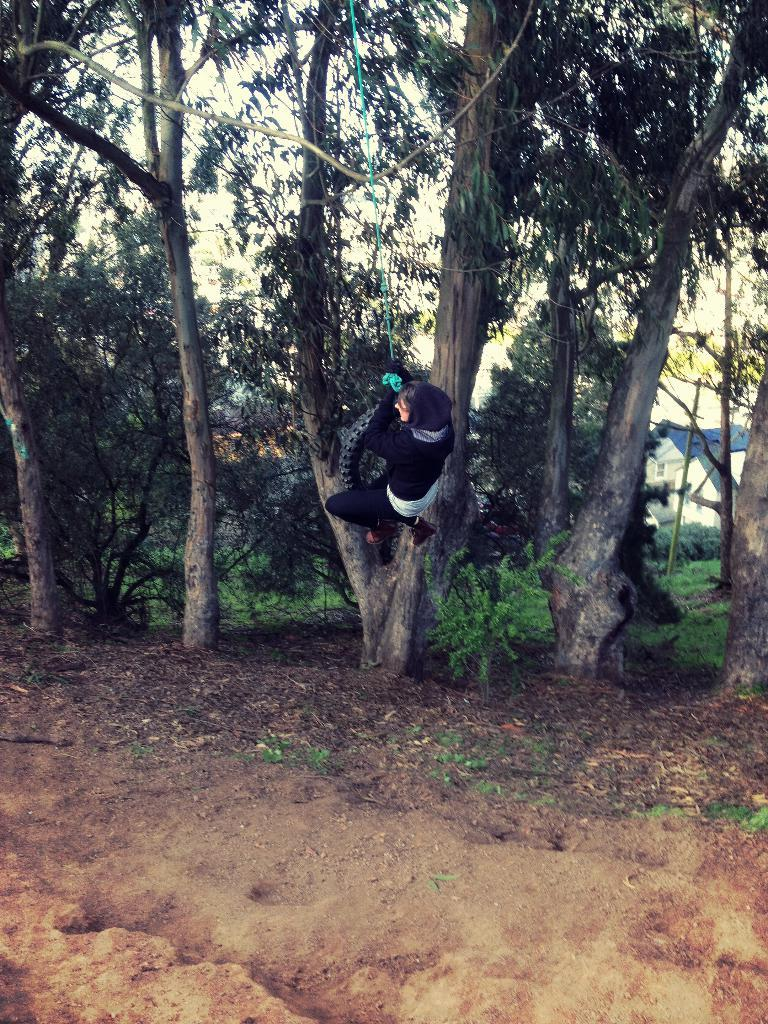What is at the bottom of the image? There is a ground at the bottom of the image. What can be seen behind the ground? There are many trees behind the ground. What type of houses are visible in the background? There are houses with blue roofs in the background. What is visible in the sky in the background? The sky is visible in the background. How many cannons are placed on the ground in the image? There are no cannons present in the image. What type of coach can be seen driving through the trees in the image? There is no coach visible in the image; only trees are present in the background. 